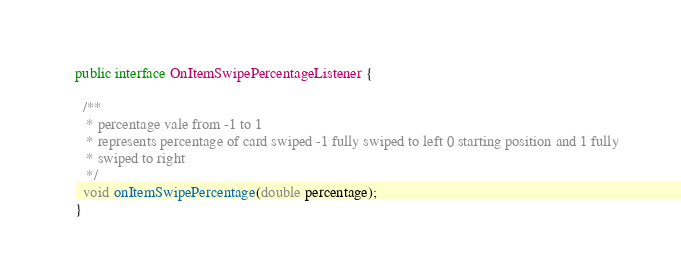Convert code to text. <code><loc_0><loc_0><loc_500><loc_500><_Java_>public interface OnItemSwipePercentageListener {

  /**
   * percentage vale from -1 to 1
   * represents percentage of card swiped -1 fully swiped to left 0 starting position and 1 fully
   * swiped to right
   */
  void onItemSwipePercentage(double percentage);
}
</code> 